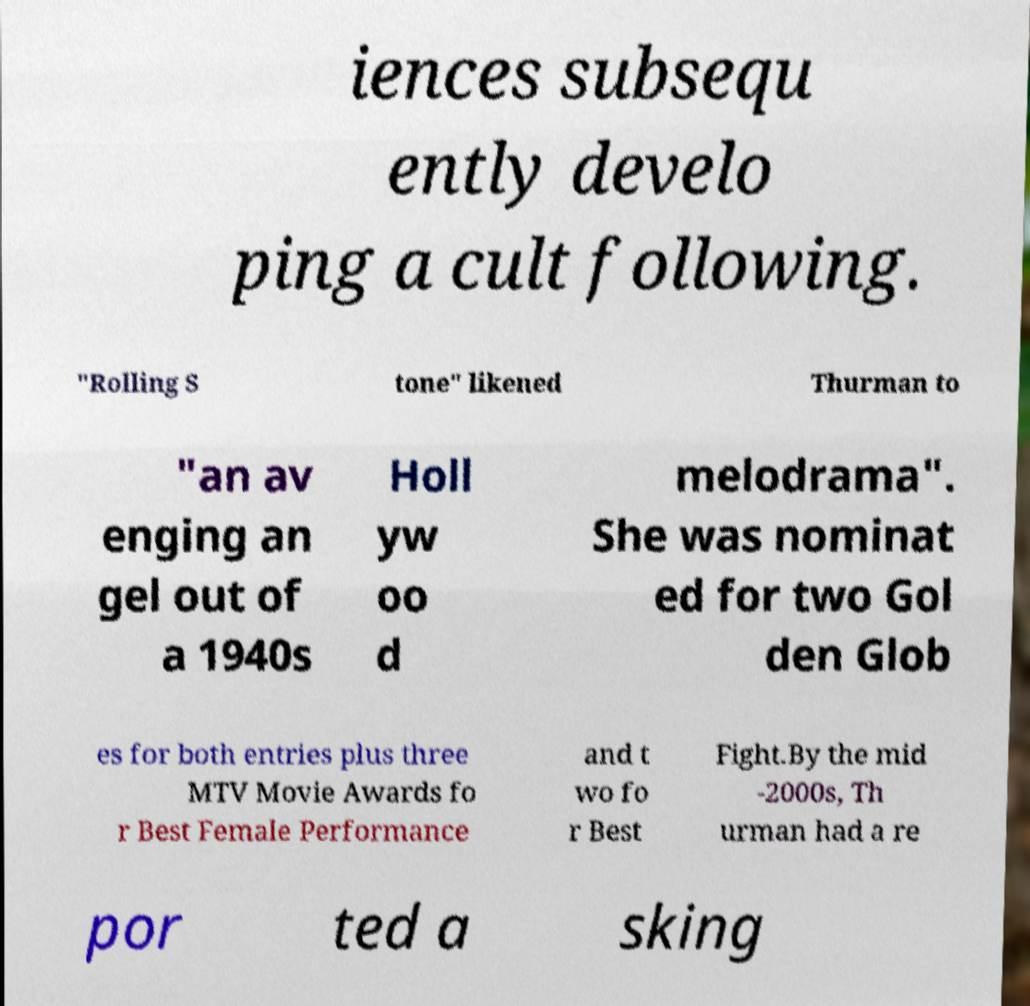Please read and relay the text visible in this image. What does it say? iences subsequ ently develo ping a cult following. "Rolling S tone" likened Thurman to "an av enging an gel out of a 1940s Holl yw oo d melodrama". She was nominat ed for two Gol den Glob es for both entries plus three MTV Movie Awards fo r Best Female Performance and t wo fo r Best Fight.By the mid -2000s, Th urman had a re por ted a sking 